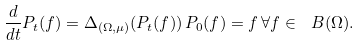Convert formula to latex. <formula><loc_0><loc_0><loc_500><loc_500>\frac { d } { d t } P _ { t } ( f ) = \Delta _ { ( \Omega , \mu ) } ( P _ { t } ( f ) ) \, P _ { 0 } ( f ) = f \, \forall f \in \ B ( \Omega ) .</formula> 